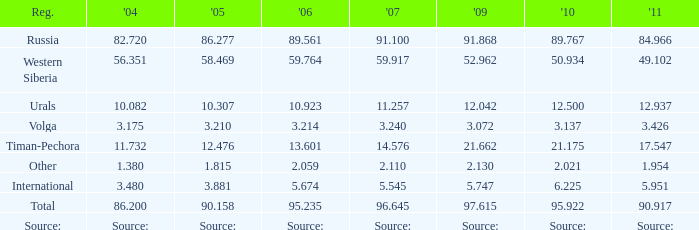What is the 2005 Lukoil oil prodroduction when in 2007 oil production 91.100 million tonnes? 86.277. 